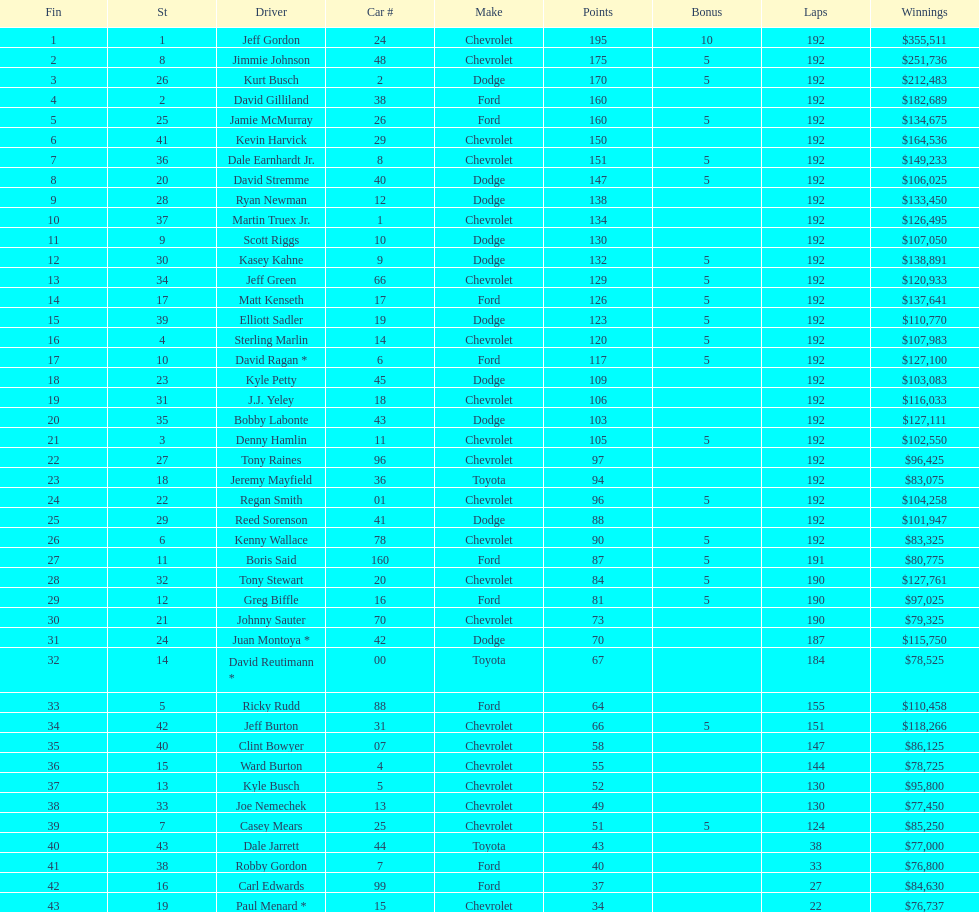Who obtained the most extra points? Jeff Gordon. 